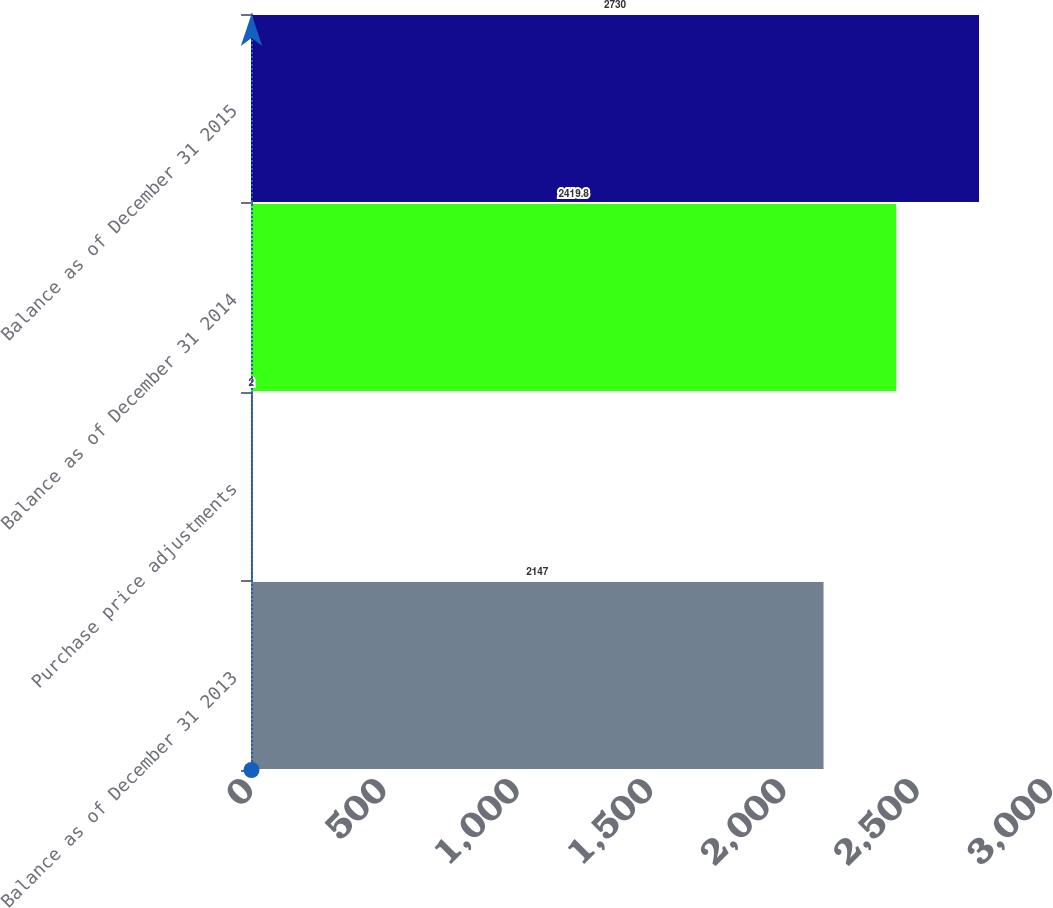<chart> <loc_0><loc_0><loc_500><loc_500><bar_chart><fcel>Balance as of December 31 2013<fcel>Purchase price adjustments<fcel>Balance as of December 31 2014<fcel>Balance as of December 31 2015<nl><fcel>2147<fcel>2<fcel>2419.8<fcel>2730<nl></chart> 